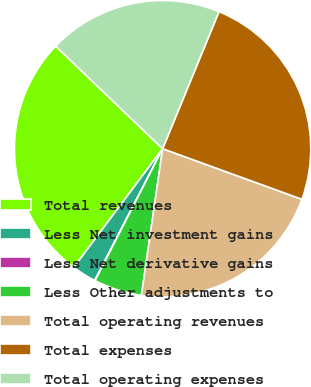Convert chart. <chart><loc_0><loc_0><loc_500><loc_500><pie_chart><fcel>Total revenues<fcel>Less Net investment gains<fcel>Less Net derivative gains<fcel>Less Other adjustments to<fcel>Total operating revenues<fcel>Total expenses<fcel>Total operating expenses<nl><fcel>26.95%<fcel>2.65%<fcel>0.04%<fcel>5.25%<fcel>21.74%<fcel>24.34%<fcel>19.04%<nl></chart> 